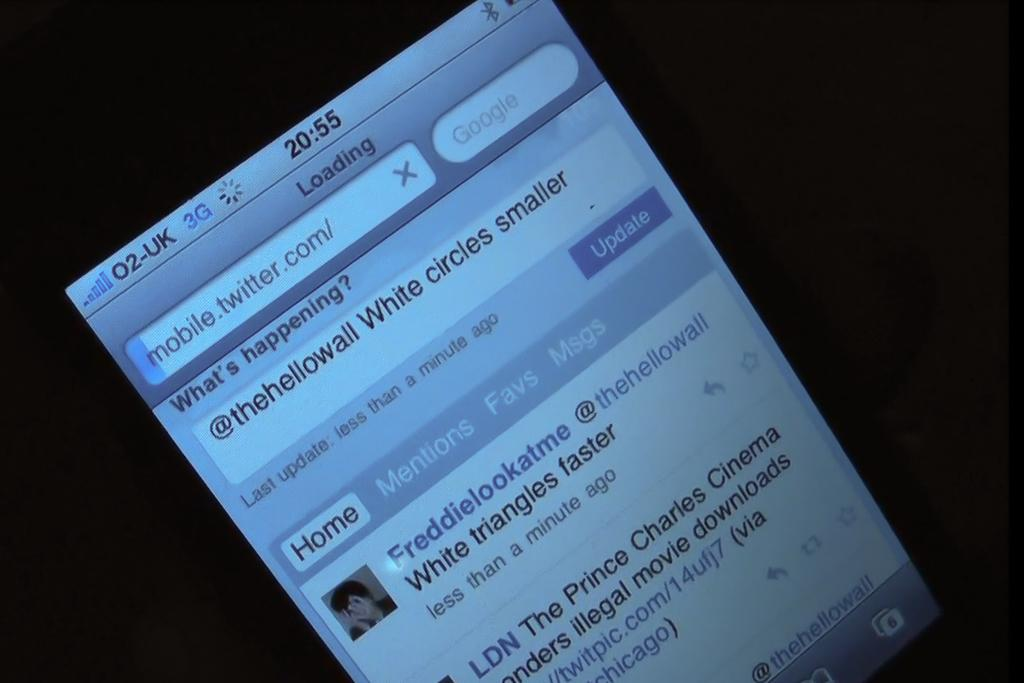Provide a one-sentence caption for the provided image. Someone is looking at Twitter on their cell phone at 20:55. 